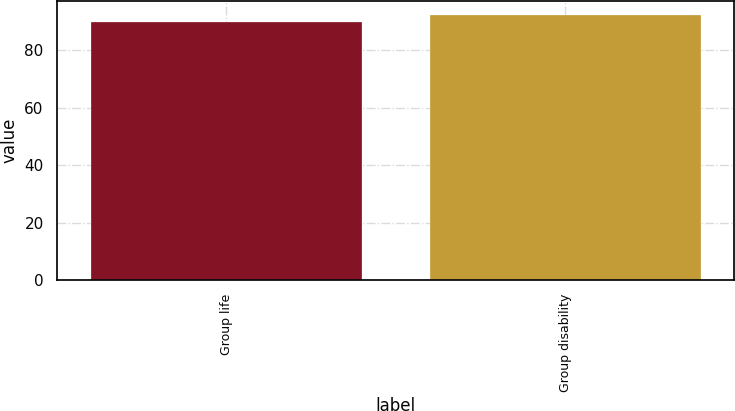Convert chart. <chart><loc_0><loc_0><loc_500><loc_500><bar_chart><fcel>Group life<fcel>Group disability<nl><fcel>89.9<fcel>92.4<nl></chart> 